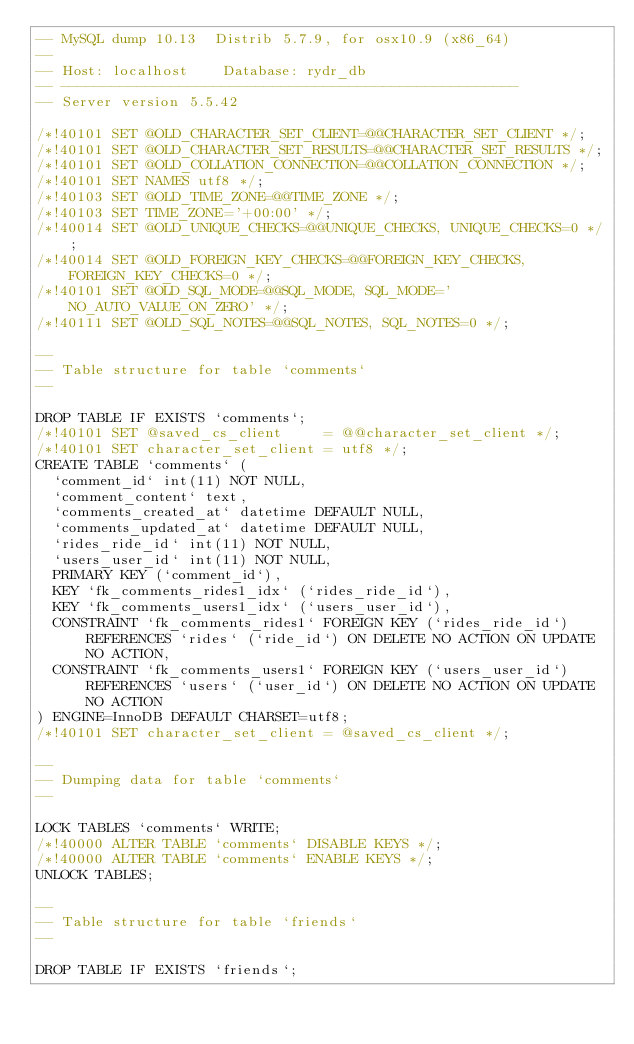<code> <loc_0><loc_0><loc_500><loc_500><_SQL_>-- MySQL dump 10.13  Distrib 5.7.9, for osx10.9 (x86_64)
--
-- Host: localhost    Database: rydr_db
-- ------------------------------------------------------
-- Server version	5.5.42

/*!40101 SET @OLD_CHARACTER_SET_CLIENT=@@CHARACTER_SET_CLIENT */;
/*!40101 SET @OLD_CHARACTER_SET_RESULTS=@@CHARACTER_SET_RESULTS */;
/*!40101 SET @OLD_COLLATION_CONNECTION=@@COLLATION_CONNECTION */;
/*!40101 SET NAMES utf8 */;
/*!40103 SET @OLD_TIME_ZONE=@@TIME_ZONE */;
/*!40103 SET TIME_ZONE='+00:00' */;
/*!40014 SET @OLD_UNIQUE_CHECKS=@@UNIQUE_CHECKS, UNIQUE_CHECKS=0 */;
/*!40014 SET @OLD_FOREIGN_KEY_CHECKS=@@FOREIGN_KEY_CHECKS, FOREIGN_KEY_CHECKS=0 */;
/*!40101 SET @OLD_SQL_MODE=@@SQL_MODE, SQL_MODE='NO_AUTO_VALUE_ON_ZERO' */;
/*!40111 SET @OLD_SQL_NOTES=@@SQL_NOTES, SQL_NOTES=0 */;

--
-- Table structure for table `comments`
--

DROP TABLE IF EXISTS `comments`;
/*!40101 SET @saved_cs_client     = @@character_set_client */;
/*!40101 SET character_set_client = utf8 */;
CREATE TABLE `comments` (
  `comment_id` int(11) NOT NULL,
  `comment_content` text,
  `comments_created_at` datetime DEFAULT NULL,
  `comments_updated_at` datetime DEFAULT NULL,
  `rides_ride_id` int(11) NOT NULL,
  `users_user_id` int(11) NOT NULL,
  PRIMARY KEY (`comment_id`),
  KEY `fk_comments_rides1_idx` (`rides_ride_id`),
  KEY `fk_comments_users1_idx` (`users_user_id`),
  CONSTRAINT `fk_comments_rides1` FOREIGN KEY (`rides_ride_id`) REFERENCES `rides` (`ride_id`) ON DELETE NO ACTION ON UPDATE NO ACTION,
  CONSTRAINT `fk_comments_users1` FOREIGN KEY (`users_user_id`) REFERENCES `users` (`user_id`) ON DELETE NO ACTION ON UPDATE NO ACTION
) ENGINE=InnoDB DEFAULT CHARSET=utf8;
/*!40101 SET character_set_client = @saved_cs_client */;

--
-- Dumping data for table `comments`
--

LOCK TABLES `comments` WRITE;
/*!40000 ALTER TABLE `comments` DISABLE KEYS */;
/*!40000 ALTER TABLE `comments` ENABLE KEYS */;
UNLOCK TABLES;

--
-- Table structure for table `friends`
--

DROP TABLE IF EXISTS `friends`;</code> 